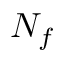Convert formula to latex. <formula><loc_0><loc_0><loc_500><loc_500>N _ { f }</formula> 